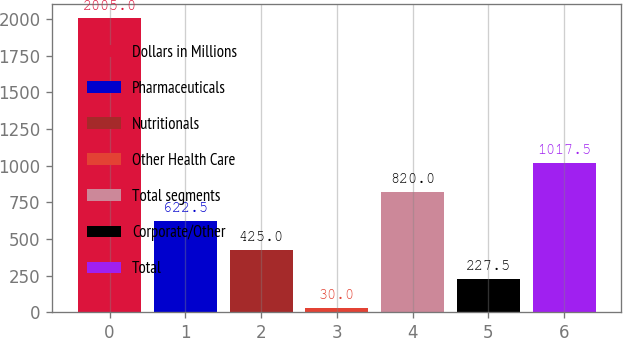<chart> <loc_0><loc_0><loc_500><loc_500><bar_chart><fcel>Dollars in Millions<fcel>Pharmaceuticals<fcel>Nutritionals<fcel>Other Health Care<fcel>Total segments<fcel>Corporate/Other<fcel>Total<nl><fcel>2005<fcel>622.5<fcel>425<fcel>30<fcel>820<fcel>227.5<fcel>1017.5<nl></chart> 